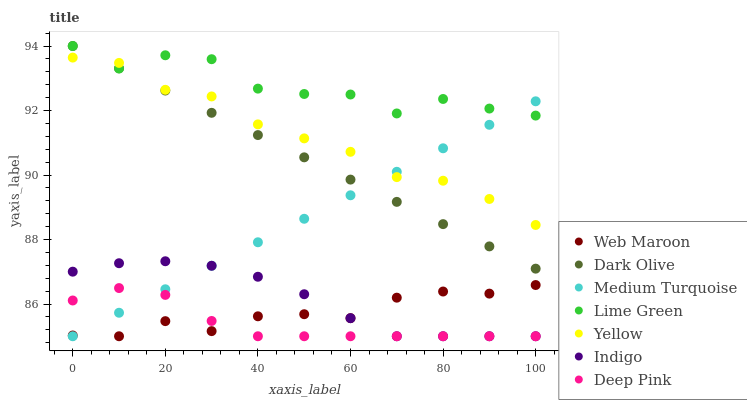Does Deep Pink have the minimum area under the curve?
Answer yes or no. Yes. Does Lime Green have the maximum area under the curve?
Answer yes or no. Yes. Does Indigo have the minimum area under the curve?
Answer yes or no. No. Does Indigo have the maximum area under the curve?
Answer yes or no. No. Is Medium Turquoise the smoothest?
Answer yes or no. Yes. Is Lime Green the roughest?
Answer yes or no. Yes. Is Indigo the smoothest?
Answer yes or no. No. Is Indigo the roughest?
Answer yes or no. No. Does Deep Pink have the lowest value?
Answer yes or no. Yes. Does Dark Olive have the lowest value?
Answer yes or no. No. Does Lime Green have the highest value?
Answer yes or no. Yes. Does Indigo have the highest value?
Answer yes or no. No. Is Web Maroon less than Yellow?
Answer yes or no. Yes. Is Lime Green greater than Deep Pink?
Answer yes or no. Yes. Does Medium Turquoise intersect Dark Olive?
Answer yes or no. Yes. Is Medium Turquoise less than Dark Olive?
Answer yes or no. No. Is Medium Turquoise greater than Dark Olive?
Answer yes or no. No. Does Web Maroon intersect Yellow?
Answer yes or no. No. 